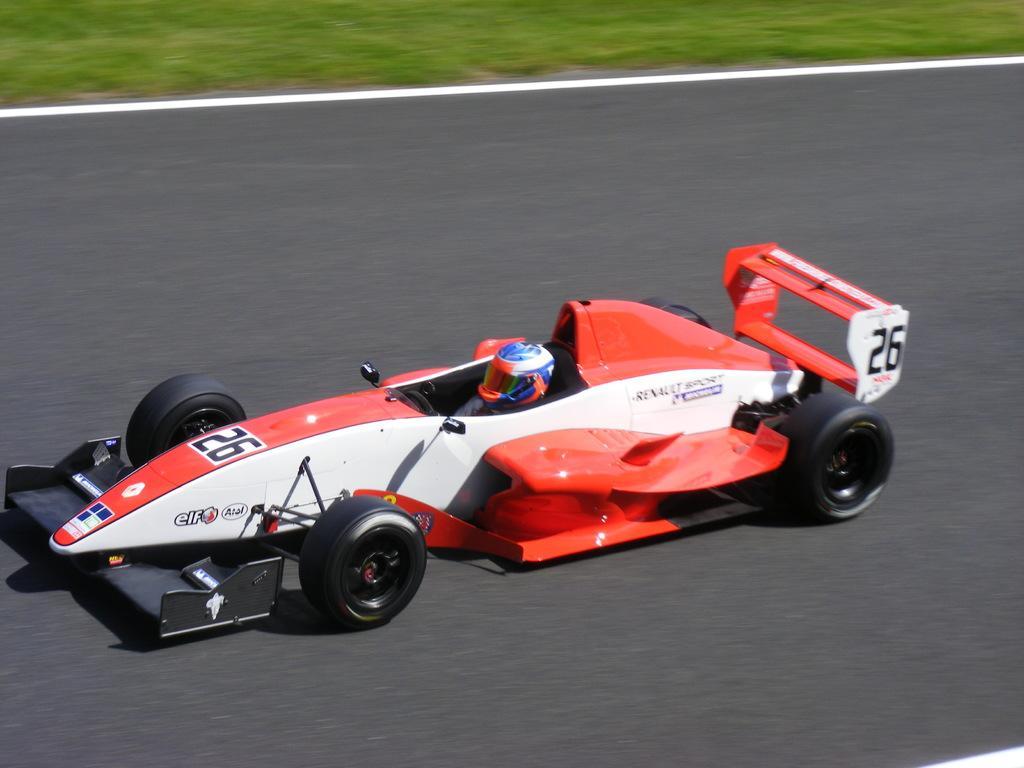Describe this image in one or two sentences. This image is taken outdoors. At the top of the image there is a ground with grass on it. At the bottom of the image there is a road. In the middle of the image we can see a man driving Go-Karting on the road. 